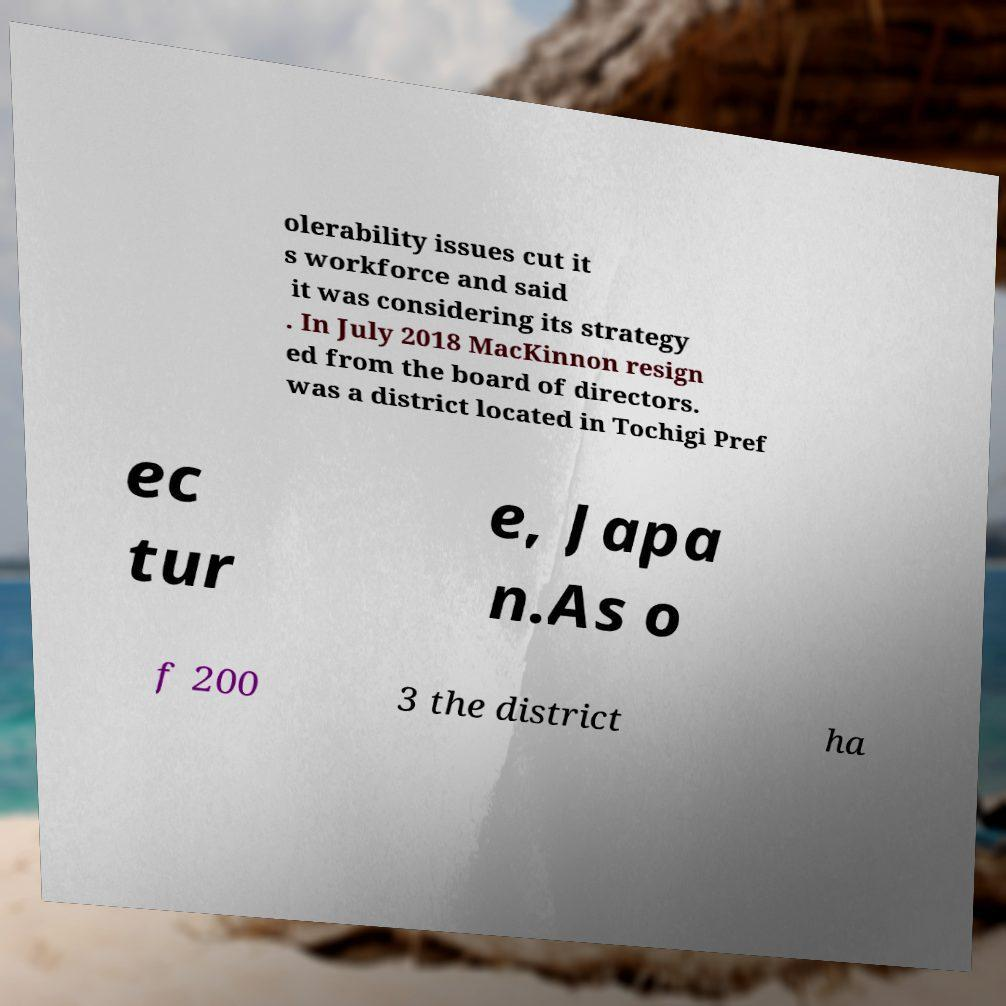There's text embedded in this image that I need extracted. Can you transcribe it verbatim? olerability issues cut it s workforce and said it was considering its strategy . In July 2018 MacKinnon resign ed from the board of directors. was a district located in Tochigi Pref ec tur e, Japa n.As o f 200 3 the district ha 